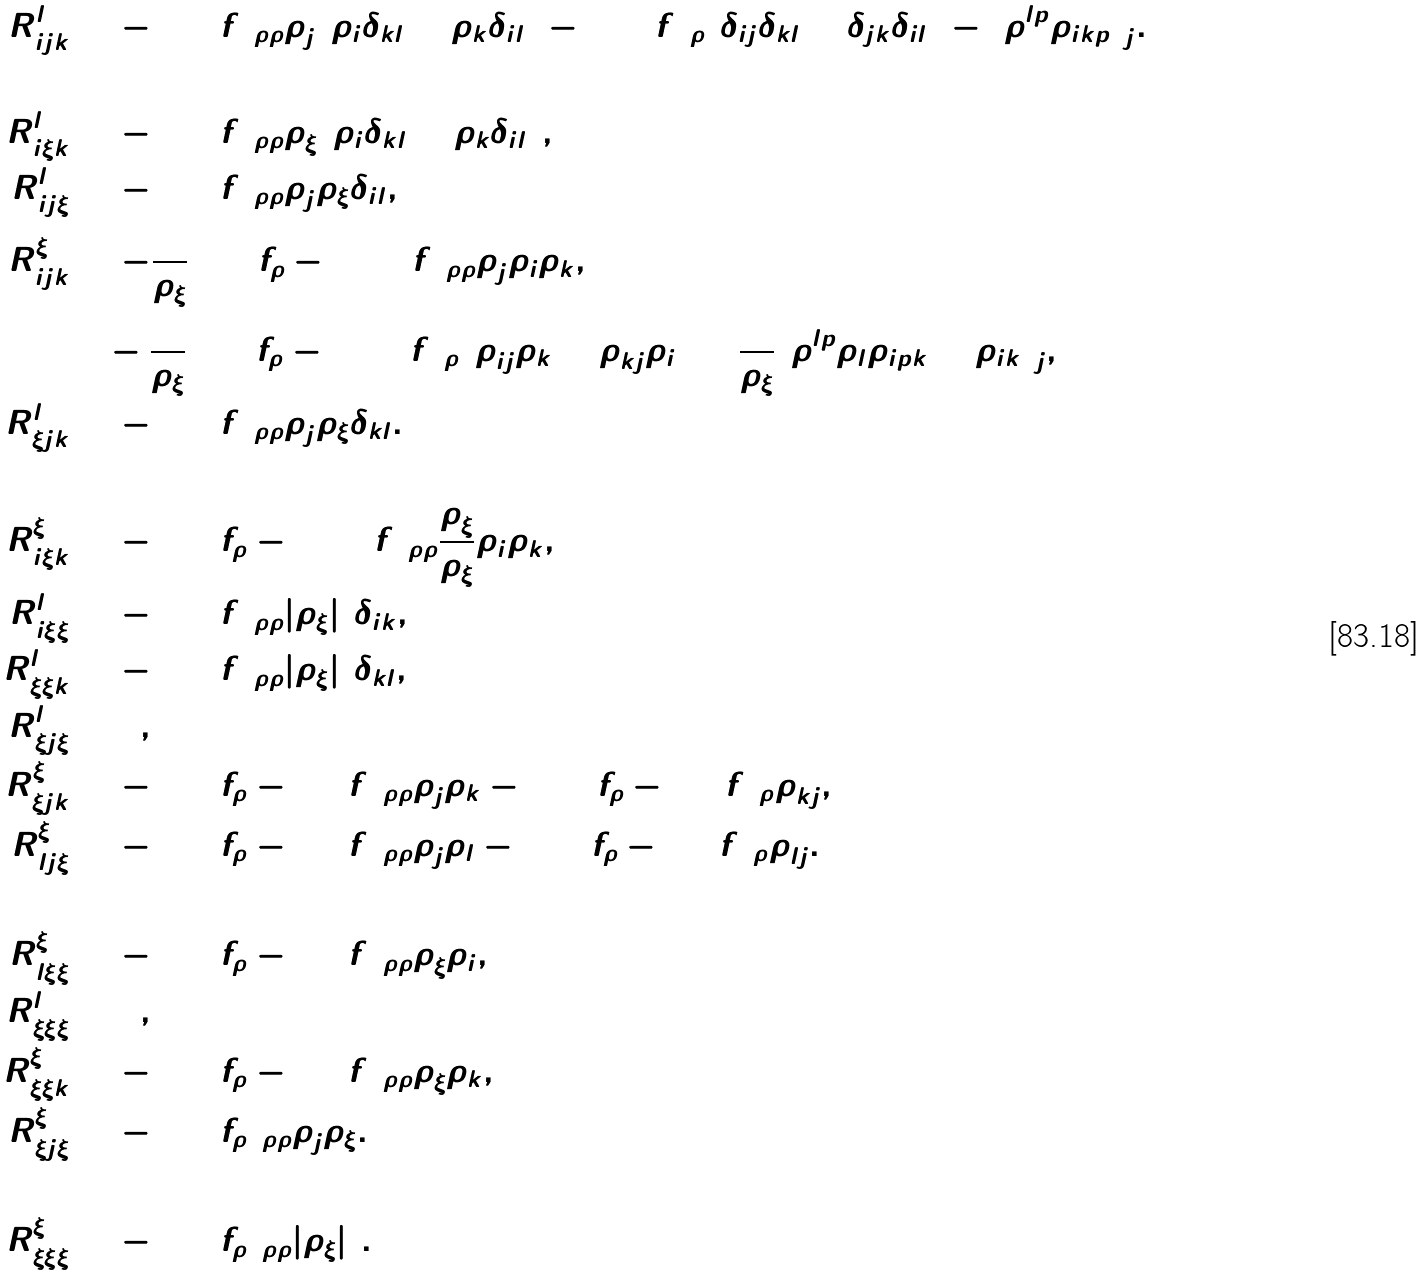Convert formula to latex. <formula><loc_0><loc_0><loc_500><loc_500>R _ { i \bar { j } k } ^ { l } & = - ( \log f ) _ { \rho \rho } \rho _ { \bar { j } } ( \rho _ { i } \delta _ { k l } + \rho _ { k } \delta _ { i l } ) - ( \log f ) _ { \rho } ( \delta _ { i j } \delta _ { k l } + \delta _ { j k } \delta _ { i l } ) - ( \rho ^ { l \bar { p } } \rho _ { i k \bar { p } } ) _ { \bar { j } } . \\ \\ R _ { i \bar { \xi } k } ^ { l } & = - ( \log f ) _ { \rho \rho } \rho _ { \bar { \xi } } ( \rho _ { i } \delta _ { k l } + \rho _ { k } \delta _ { i l } ) , \\ R _ { i \bar { j } \xi } ^ { l } & = - ( \log f ) _ { \rho \rho } \rho _ { \bar { j } } \rho _ { \xi } \delta _ { i l } , \\ R _ { i \bar { j } k } ^ { \xi } & = - \frac { 1 } { \rho _ { \xi } } ( \log f _ { \rho } - 2 \log f ) _ { \rho \rho } \rho _ { \bar { j } } \rho _ { i } \rho _ { k } , \\ & \quad - \frac { 1 } { \rho _ { \xi } } ( \log f _ { \rho } - 2 \log f ) _ { \rho } ( \rho _ { i \bar { j } } \rho _ { k } + \rho _ { k \bar { j } } \rho _ { i } ) + \frac { 1 } { \rho _ { \xi } } ( \rho ^ { l \bar { p } } \rho _ { l } \rho _ { i \bar { p } k } + \rho _ { i k } ) _ { \bar { j } } , \\ R _ { \xi \bar { j } k } ^ { l } & = - ( \log f ) _ { \rho \rho } \rho _ { \bar { j } } \rho _ { \xi } \delta _ { k l } . \\ \\ R _ { i \bar { \xi } k } ^ { \xi } & = - ( \log f _ { \rho } - 2 \log f ) _ { \rho \rho } \frac { \rho _ { \bar { \xi } } } { \rho _ { \xi } } \rho _ { i } \rho _ { k } , \\ R _ { i \bar { \xi } \xi } ^ { l } & = - ( \log f ) _ { \rho \rho } | \rho _ { \xi } | ^ { 2 } \delta _ { i k } , \\ R _ { \xi \bar { \xi } k } ^ { l } & = - ( \log f ) _ { \rho \rho } | \rho _ { \xi } | ^ { 2 } \delta _ { k l } , \\ R _ { \xi \bar { j } \xi } ^ { l } & = 0 , \\ R _ { \xi \bar { j } k } ^ { \xi } & = - ( \log f _ { \rho } - \log f ) _ { \rho \rho } \rho _ { \bar { j } } \rho _ { k } - ( \log f _ { \rho } - \log f ) _ { \rho } \rho _ { k \bar { j } } , \\ R _ { l \bar { j } \xi } ^ { \xi } & = - ( \log f _ { \rho } - \log f ) _ { \rho \rho } \rho _ { \bar { j } } \rho _ { l } - ( \log f _ { \rho } - \log f ) _ { \rho } \rho _ { l \bar { j } } . \\ \\ R _ { l \bar { \xi } \xi } ^ { \xi } & = - ( \log f _ { \rho } - \log f ) _ { \rho \rho } \rho _ { \bar { \xi } } \rho _ { i } , \\ R _ { \xi \bar { \xi } \xi } ^ { l } & = 0 , \\ R _ { \xi \bar { \xi } k } ^ { \xi } & = - ( \log f _ { \rho } - \log f ) _ { \rho \rho } \rho _ { \bar { \xi } } \rho _ { k } , \\ R _ { \xi \bar { j } \xi } ^ { \xi } & = - ( \log f _ { \rho } ) _ { \rho \rho } \rho _ { \bar { j } } \rho _ { \xi } . \\ \\ R _ { \xi \bar { \xi } \xi } ^ { \xi } & = - ( \log f _ { \rho } ) _ { \rho \rho } | \rho _ { \xi } | ^ { 2 } .</formula> 